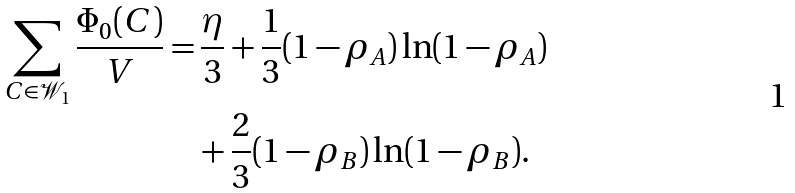<formula> <loc_0><loc_0><loc_500><loc_500>\sum _ { C \in \mathcal { W } _ { 1 } } \frac { \Phi _ { 0 } ( C ) } { V } = & \, \frac { \eta } { 3 } + \frac { 1 } { 3 } ( 1 - \rho _ { A } ) \ln ( 1 - \rho _ { A } ) \\ & + \frac { 2 } { 3 } ( 1 - \rho _ { B } ) \ln ( 1 - \rho _ { B } ) .</formula> 